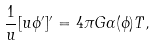Convert formula to latex. <formula><loc_0><loc_0><loc_500><loc_500>\frac { 1 } { u } [ u \phi ^ { \prime } ] ^ { \prime } = 4 \pi G \alpha ( \phi ) T ,</formula> 